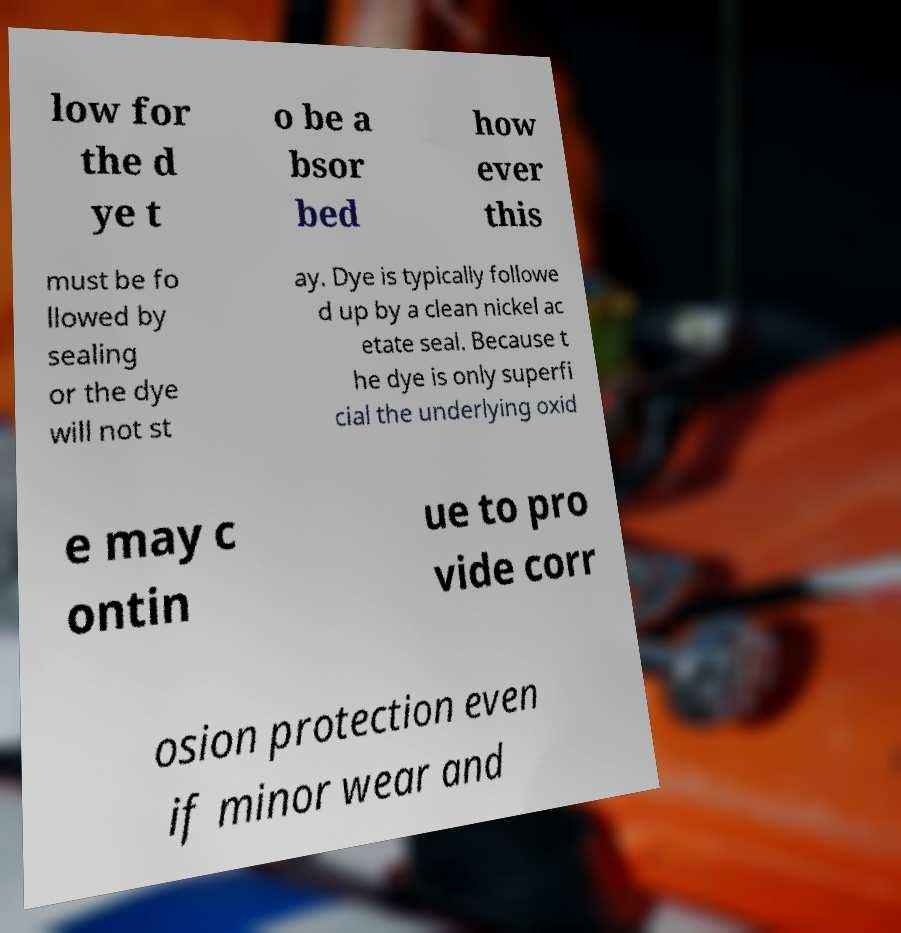There's text embedded in this image that I need extracted. Can you transcribe it verbatim? low for the d ye t o be a bsor bed how ever this must be fo llowed by sealing or the dye will not st ay. Dye is typically followe d up by a clean nickel ac etate seal. Because t he dye is only superfi cial the underlying oxid e may c ontin ue to pro vide corr osion protection even if minor wear and 